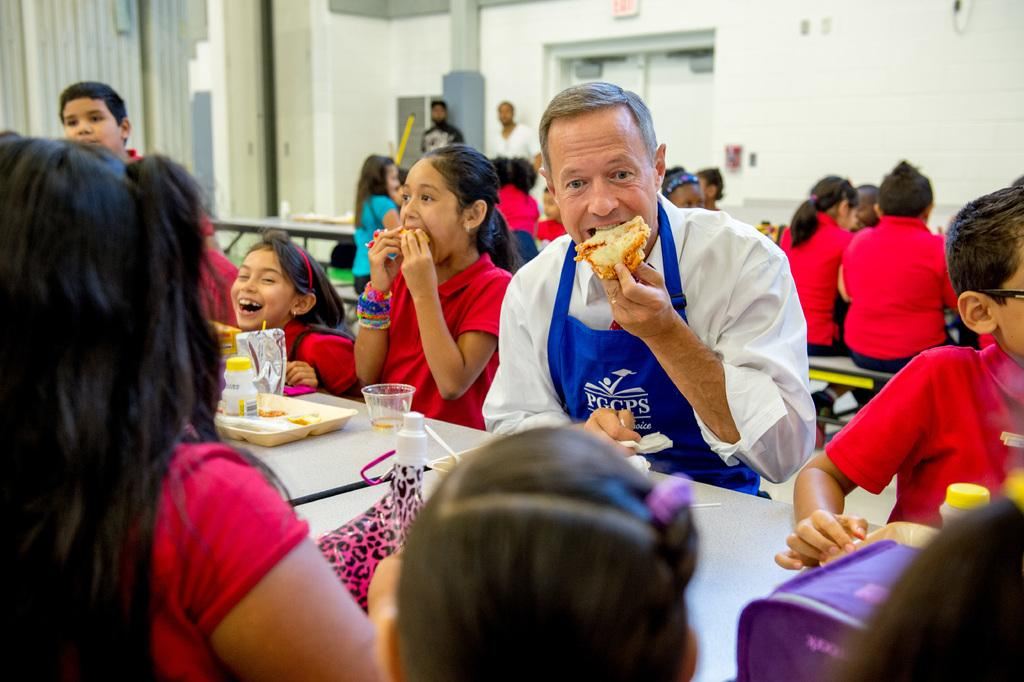How many kids can be seen in the image? There are many kids in the image. What are the kids doing in the image? The kids are eating at a table in the image. Who is the person in the image preparing or serving the food? There is a chef in the image. What is the chef holding in one hand? The chef is holding a food item in one hand. What can be seen in the background of the image? There is an exit door visible in the background of the image. Where is the shop located in the image? There is no shop present in the image. What type of sack is being used by the kids in the image? There are no sacks visible in the image; the kids are eating at a table. 